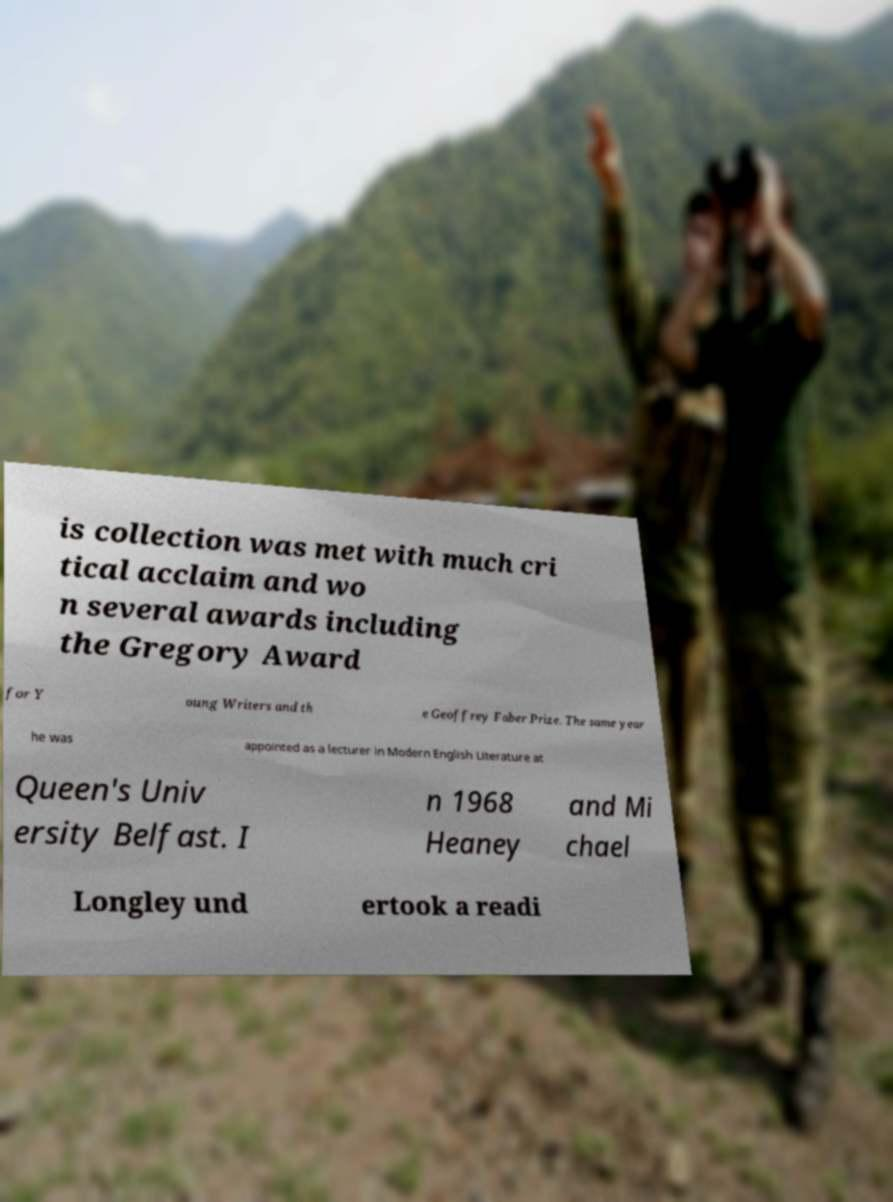Please identify and transcribe the text found in this image. is collection was met with much cri tical acclaim and wo n several awards including the Gregory Award for Y oung Writers and th e Geoffrey Faber Prize. The same year he was appointed as a lecturer in Modern English Literature at Queen's Univ ersity Belfast. I n 1968 Heaney and Mi chael Longley und ertook a readi 